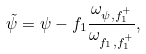<formula> <loc_0><loc_0><loc_500><loc_500>\tilde { \psi } = \psi - f _ { 1 } \frac { \omega _ { \psi , f _ { 1 } ^ { + } } } { \omega _ { f _ { 1 } , f _ { 1 } ^ { + } } } ,</formula> 